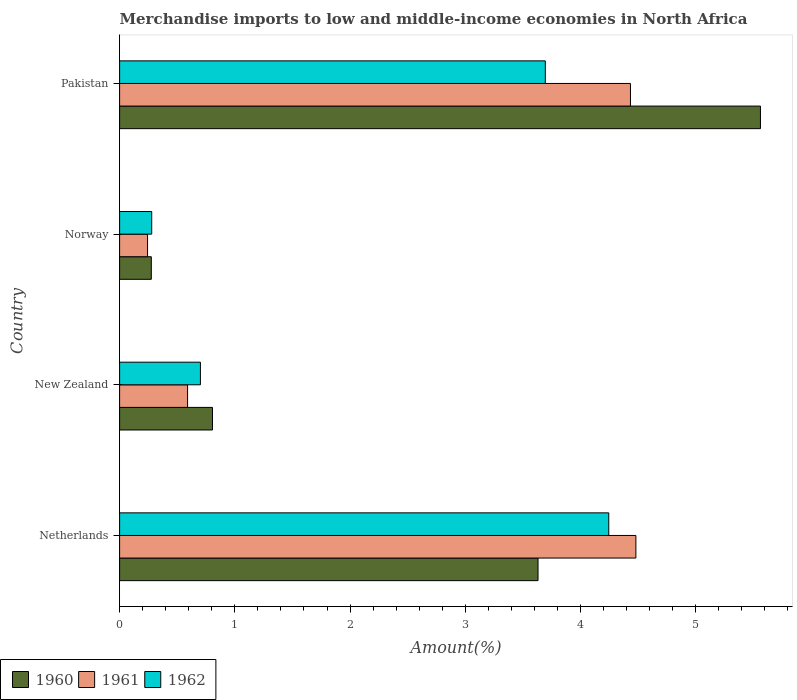How many groups of bars are there?
Offer a terse response. 4. Are the number of bars per tick equal to the number of legend labels?
Offer a terse response. Yes. Are the number of bars on each tick of the Y-axis equal?
Your answer should be compact. Yes. How many bars are there on the 2nd tick from the top?
Offer a very short reply. 3. In how many cases, is the number of bars for a given country not equal to the number of legend labels?
Offer a very short reply. 0. What is the percentage of amount earned from merchandise imports in 1961 in Netherlands?
Offer a very short reply. 4.48. Across all countries, what is the maximum percentage of amount earned from merchandise imports in 1960?
Your answer should be compact. 5.56. Across all countries, what is the minimum percentage of amount earned from merchandise imports in 1962?
Your response must be concise. 0.28. In which country was the percentage of amount earned from merchandise imports in 1962 maximum?
Keep it short and to the point. Netherlands. In which country was the percentage of amount earned from merchandise imports in 1962 minimum?
Make the answer very short. Norway. What is the total percentage of amount earned from merchandise imports in 1961 in the graph?
Give a very brief answer. 9.75. What is the difference between the percentage of amount earned from merchandise imports in 1961 in Norway and that in Pakistan?
Your response must be concise. -4.19. What is the difference between the percentage of amount earned from merchandise imports in 1962 in Netherlands and the percentage of amount earned from merchandise imports in 1961 in Norway?
Offer a terse response. 4. What is the average percentage of amount earned from merchandise imports in 1960 per country?
Ensure brevity in your answer.  2.57. What is the difference between the percentage of amount earned from merchandise imports in 1960 and percentage of amount earned from merchandise imports in 1962 in Pakistan?
Provide a short and direct response. 1.87. In how many countries, is the percentage of amount earned from merchandise imports in 1961 greater than 5.4 %?
Provide a short and direct response. 0. What is the ratio of the percentage of amount earned from merchandise imports in 1962 in New Zealand to that in Pakistan?
Provide a short and direct response. 0.19. Is the percentage of amount earned from merchandise imports in 1960 in Netherlands less than that in Pakistan?
Ensure brevity in your answer.  Yes. Is the difference between the percentage of amount earned from merchandise imports in 1960 in Netherlands and New Zealand greater than the difference between the percentage of amount earned from merchandise imports in 1962 in Netherlands and New Zealand?
Your answer should be very brief. No. What is the difference between the highest and the second highest percentage of amount earned from merchandise imports in 1961?
Give a very brief answer. 0.05. What is the difference between the highest and the lowest percentage of amount earned from merchandise imports in 1960?
Your answer should be very brief. 5.29. What does the 3rd bar from the top in Pakistan represents?
Ensure brevity in your answer.  1960. What does the 2nd bar from the bottom in New Zealand represents?
Give a very brief answer. 1961. Is it the case that in every country, the sum of the percentage of amount earned from merchandise imports in 1960 and percentage of amount earned from merchandise imports in 1961 is greater than the percentage of amount earned from merchandise imports in 1962?
Your answer should be compact. Yes. Are all the bars in the graph horizontal?
Make the answer very short. Yes. What is the difference between two consecutive major ticks on the X-axis?
Ensure brevity in your answer.  1. What is the title of the graph?
Your answer should be very brief. Merchandise imports to low and middle-income economies in North Africa. Does "1980" appear as one of the legend labels in the graph?
Make the answer very short. No. What is the label or title of the X-axis?
Make the answer very short. Amount(%). What is the Amount(%) of 1960 in Netherlands?
Your answer should be compact. 3.63. What is the Amount(%) of 1961 in Netherlands?
Your answer should be compact. 4.48. What is the Amount(%) in 1962 in Netherlands?
Your response must be concise. 4.25. What is the Amount(%) of 1960 in New Zealand?
Provide a short and direct response. 0.81. What is the Amount(%) of 1961 in New Zealand?
Keep it short and to the point. 0.59. What is the Amount(%) in 1962 in New Zealand?
Your response must be concise. 0.7. What is the Amount(%) in 1960 in Norway?
Provide a short and direct response. 0.28. What is the Amount(%) in 1961 in Norway?
Provide a succinct answer. 0.24. What is the Amount(%) in 1962 in Norway?
Provide a short and direct response. 0.28. What is the Amount(%) in 1960 in Pakistan?
Offer a terse response. 5.56. What is the Amount(%) of 1961 in Pakistan?
Your response must be concise. 4.43. What is the Amount(%) in 1962 in Pakistan?
Make the answer very short. 3.69. Across all countries, what is the maximum Amount(%) in 1960?
Your answer should be very brief. 5.56. Across all countries, what is the maximum Amount(%) in 1961?
Your response must be concise. 4.48. Across all countries, what is the maximum Amount(%) in 1962?
Give a very brief answer. 4.25. Across all countries, what is the minimum Amount(%) of 1960?
Provide a short and direct response. 0.28. Across all countries, what is the minimum Amount(%) in 1961?
Provide a short and direct response. 0.24. Across all countries, what is the minimum Amount(%) of 1962?
Keep it short and to the point. 0.28. What is the total Amount(%) of 1960 in the graph?
Your answer should be very brief. 10.27. What is the total Amount(%) in 1961 in the graph?
Provide a succinct answer. 9.75. What is the total Amount(%) in 1962 in the graph?
Make the answer very short. 8.92. What is the difference between the Amount(%) of 1960 in Netherlands and that in New Zealand?
Keep it short and to the point. 2.83. What is the difference between the Amount(%) in 1961 in Netherlands and that in New Zealand?
Offer a very short reply. 3.89. What is the difference between the Amount(%) of 1962 in Netherlands and that in New Zealand?
Provide a short and direct response. 3.54. What is the difference between the Amount(%) in 1960 in Netherlands and that in Norway?
Offer a very short reply. 3.36. What is the difference between the Amount(%) in 1961 in Netherlands and that in Norway?
Give a very brief answer. 4.24. What is the difference between the Amount(%) in 1962 in Netherlands and that in Norway?
Provide a succinct answer. 3.97. What is the difference between the Amount(%) in 1960 in Netherlands and that in Pakistan?
Offer a very short reply. -1.93. What is the difference between the Amount(%) of 1961 in Netherlands and that in Pakistan?
Give a very brief answer. 0.05. What is the difference between the Amount(%) of 1962 in Netherlands and that in Pakistan?
Your answer should be compact. 0.55. What is the difference between the Amount(%) of 1960 in New Zealand and that in Norway?
Offer a very short reply. 0.53. What is the difference between the Amount(%) of 1961 in New Zealand and that in Norway?
Make the answer very short. 0.35. What is the difference between the Amount(%) in 1962 in New Zealand and that in Norway?
Ensure brevity in your answer.  0.42. What is the difference between the Amount(%) of 1960 in New Zealand and that in Pakistan?
Your answer should be compact. -4.76. What is the difference between the Amount(%) in 1961 in New Zealand and that in Pakistan?
Offer a terse response. -3.84. What is the difference between the Amount(%) of 1962 in New Zealand and that in Pakistan?
Your response must be concise. -2.99. What is the difference between the Amount(%) in 1960 in Norway and that in Pakistan?
Your response must be concise. -5.29. What is the difference between the Amount(%) in 1961 in Norway and that in Pakistan?
Keep it short and to the point. -4.19. What is the difference between the Amount(%) of 1962 in Norway and that in Pakistan?
Offer a very short reply. -3.42. What is the difference between the Amount(%) in 1960 in Netherlands and the Amount(%) in 1961 in New Zealand?
Provide a succinct answer. 3.04. What is the difference between the Amount(%) in 1960 in Netherlands and the Amount(%) in 1962 in New Zealand?
Keep it short and to the point. 2.93. What is the difference between the Amount(%) of 1961 in Netherlands and the Amount(%) of 1962 in New Zealand?
Offer a very short reply. 3.78. What is the difference between the Amount(%) in 1960 in Netherlands and the Amount(%) in 1961 in Norway?
Offer a very short reply. 3.39. What is the difference between the Amount(%) of 1960 in Netherlands and the Amount(%) of 1962 in Norway?
Offer a terse response. 3.35. What is the difference between the Amount(%) of 1961 in Netherlands and the Amount(%) of 1962 in Norway?
Your answer should be very brief. 4.2. What is the difference between the Amount(%) of 1960 in Netherlands and the Amount(%) of 1961 in Pakistan?
Offer a very short reply. -0.8. What is the difference between the Amount(%) of 1960 in Netherlands and the Amount(%) of 1962 in Pakistan?
Provide a succinct answer. -0.06. What is the difference between the Amount(%) in 1961 in Netherlands and the Amount(%) in 1962 in Pakistan?
Your answer should be very brief. 0.79. What is the difference between the Amount(%) in 1960 in New Zealand and the Amount(%) in 1961 in Norway?
Make the answer very short. 0.56. What is the difference between the Amount(%) in 1960 in New Zealand and the Amount(%) in 1962 in Norway?
Offer a terse response. 0.53. What is the difference between the Amount(%) of 1961 in New Zealand and the Amount(%) of 1962 in Norway?
Provide a short and direct response. 0.31. What is the difference between the Amount(%) of 1960 in New Zealand and the Amount(%) of 1961 in Pakistan?
Offer a terse response. -3.63. What is the difference between the Amount(%) of 1960 in New Zealand and the Amount(%) of 1962 in Pakistan?
Ensure brevity in your answer.  -2.89. What is the difference between the Amount(%) of 1961 in New Zealand and the Amount(%) of 1962 in Pakistan?
Give a very brief answer. -3.1. What is the difference between the Amount(%) in 1960 in Norway and the Amount(%) in 1961 in Pakistan?
Your answer should be compact. -4.16. What is the difference between the Amount(%) of 1960 in Norway and the Amount(%) of 1962 in Pakistan?
Make the answer very short. -3.42. What is the difference between the Amount(%) of 1961 in Norway and the Amount(%) of 1962 in Pakistan?
Provide a short and direct response. -3.45. What is the average Amount(%) of 1960 per country?
Offer a very short reply. 2.57. What is the average Amount(%) in 1961 per country?
Offer a very short reply. 2.44. What is the average Amount(%) in 1962 per country?
Your answer should be very brief. 2.23. What is the difference between the Amount(%) in 1960 and Amount(%) in 1961 in Netherlands?
Your response must be concise. -0.85. What is the difference between the Amount(%) of 1960 and Amount(%) of 1962 in Netherlands?
Offer a terse response. -0.61. What is the difference between the Amount(%) in 1961 and Amount(%) in 1962 in Netherlands?
Make the answer very short. 0.24. What is the difference between the Amount(%) in 1960 and Amount(%) in 1961 in New Zealand?
Your response must be concise. 0.22. What is the difference between the Amount(%) of 1960 and Amount(%) of 1962 in New Zealand?
Your response must be concise. 0.1. What is the difference between the Amount(%) of 1961 and Amount(%) of 1962 in New Zealand?
Your answer should be compact. -0.11. What is the difference between the Amount(%) of 1960 and Amount(%) of 1961 in Norway?
Provide a succinct answer. 0.03. What is the difference between the Amount(%) of 1960 and Amount(%) of 1962 in Norway?
Offer a very short reply. -0. What is the difference between the Amount(%) in 1961 and Amount(%) in 1962 in Norway?
Give a very brief answer. -0.04. What is the difference between the Amount(%) in 1960 and Amount(%) in 1961 in Pakistan?
Give a very brief answer. 1.13. What is the difference between the Amount(%) of 1960 and Amount(%) of 1962 in Pakistan?
Offer a terse response. 1.87. What is the difference between the Amount(%) of 1961 and Amount(%) of 1962 in Pakistan?
Provide a succinct answer. 0.74. What is the ratio of the Amount(%) in 1960 in Netherlands to that in New Zealand?
Your answer should be compact. 4.5. What is the ratio of the Amount(%) in 1961 in Netherlands to that in New Zealand?
Your response must be concise. 7.6. What is the ratio of the Amount(%) of 1962 in Netherlands to that in New Zealand?
Provide a short and direct response. 6.05. What is the ratio of the Amount(%) in 1960 in Netherlands to that in Norway?
Your answer should be compact. 13.2. What is the ratio of the Amount(%) in 1961 in Netherlands to that in Norway?
Make the answer very short. 18.48. What is the ratio of the Amount(%) in 1962 in Netherlands to that in Norway?
Your answer should be very brief. 15.23. What is the ratio of the Amount(%) of 1960 in Netherlands to that in Pakistan?
Your answer should be very brief. 0.65. What is the ratio of the Amount(%) in 1961 in Netherlands to that in Pakistan?
Provide a succinct answer. 1.01. What is the ratio of the Amount(%) of 1962 in Netherlands to that in Pakistan?
Offer a terse response. 1.15. What is the ratio of the Amount(%) in 1960 in New Zealand to that in Norway?
Offer a very short reply. 2.93. What is the ratio of the Amount(%) of 1961 in New Zealand to that in Norway?
Provide a succinct answer. 2.43. What is the ratio of the Amount(%) in 1962 in New Zealand to that in Norway?
Offer a very short reply. 2.52. What is the ratio of the Amount(%) of 1960 in New Zealand to that in Pakistan?
Offer a very short reply. 0.14. What is the ratio of the Amount(%) in 1961 in New Zealand to that in Pakistan?
Your answer should be very brief. 0.13. What is the ratio of the Amount(%) of 1962 in New Zealand to that in Pakistan?
Your answer should be very brief. 0.19. What is the ratio of the Amount(%) of 1960 in Norway to that in Pakistan?
Make the answer very short. 0.05. What is the ratio of the Amount(%) of 1961 in Norway to that in Pakistan?
Your response must be concise. 0.05. What is the ratio of the Amount(%) in 1962 in Norway to that in Pakistan?
Give a very brief answer. 0.08. What is the difference between the highest and the second highest Amount(%) of 1960?
Give a very brief answer. 1.93. What is the difference between the highest and the second highest Amount(%) of 1961?
Provide a succinct answer. 0.05. What is the difference between the highest and the second highest Amount(%) in 1962?
Give a very brief answer. 0.55. What is the difference between the highest and the lowest Amount(%) of 1960?
Ensure brevity in your answer.  5.29. What is the difference between the highest and the lowest Amount(%) in 1961?
Make the answer very short. 4.24. What is the difference between the highest and the lowest Amount(%) in 1962?
Make the answer very short. 3.97. 